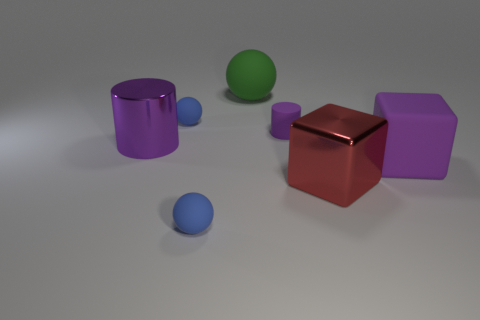There is a cylinder behind the purple metal object; is it the same color as the large cylinder?
Ensure brevity in your answer.  Yes. What number of rubber objects have the same color as the shiny cylinder?
Give a very brief answer. 2. The matte thing that is the same shape as the big purple metal object is what size?
Provide a short and direct response. Small. There is a purple matte thing behind the large cylinder; what is its size?
Ensure brevity in your answer.  Small. Is the number of objects that are in front of the large rubber cube greater than the number of metallic blocks?
Give a very brief answer. Yes. What is the shape of the red thing?
Your answer should be very brief. Cube. Is the color of the small sphere that is in front of the tiny purple cylinder the same as the small sphere that is behind the large red thing?
Ensure brevity in your answer.  Yes. Is the big purple rubber object the same shape as the big red metal object?
Your response must be concise. Yes. Is the large purple thing on the right side of the large purple shiny cylinder made of the same material as the large cylinder?
Ensure brevity in your answer.  No. There is a tiny thing that is on the left side of the matte cylinder and behind the large red shiny object; what is its shape?
Offer a very short reply. Sphere. 